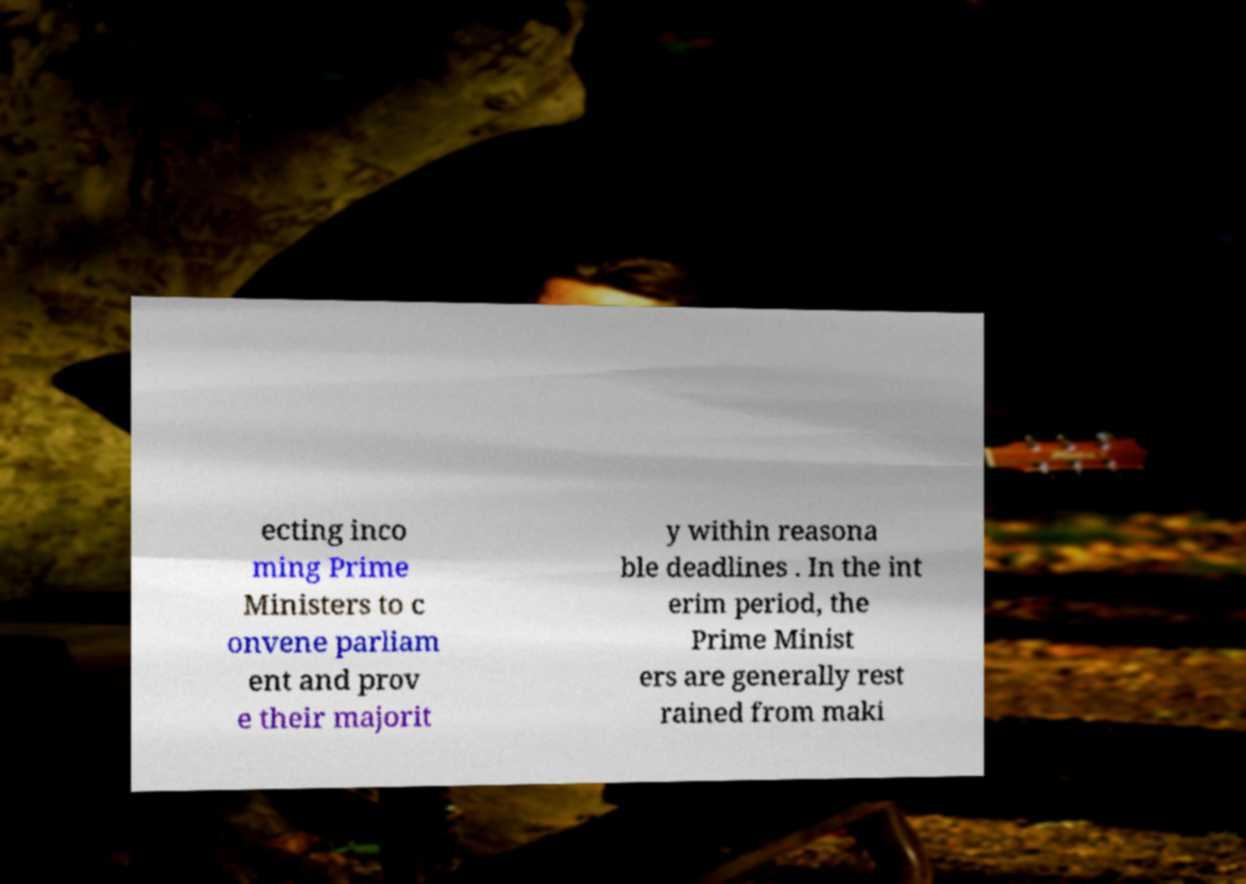For documentation purposes, I need the text within this image transcribed. Could you provide that? ecting inco ming Prime Ministers to c onvene parliam ent and prov e their majorit y within reasona ble deadlines . In the int erim period, the Prime Minist ers are generally rest rained from maki 